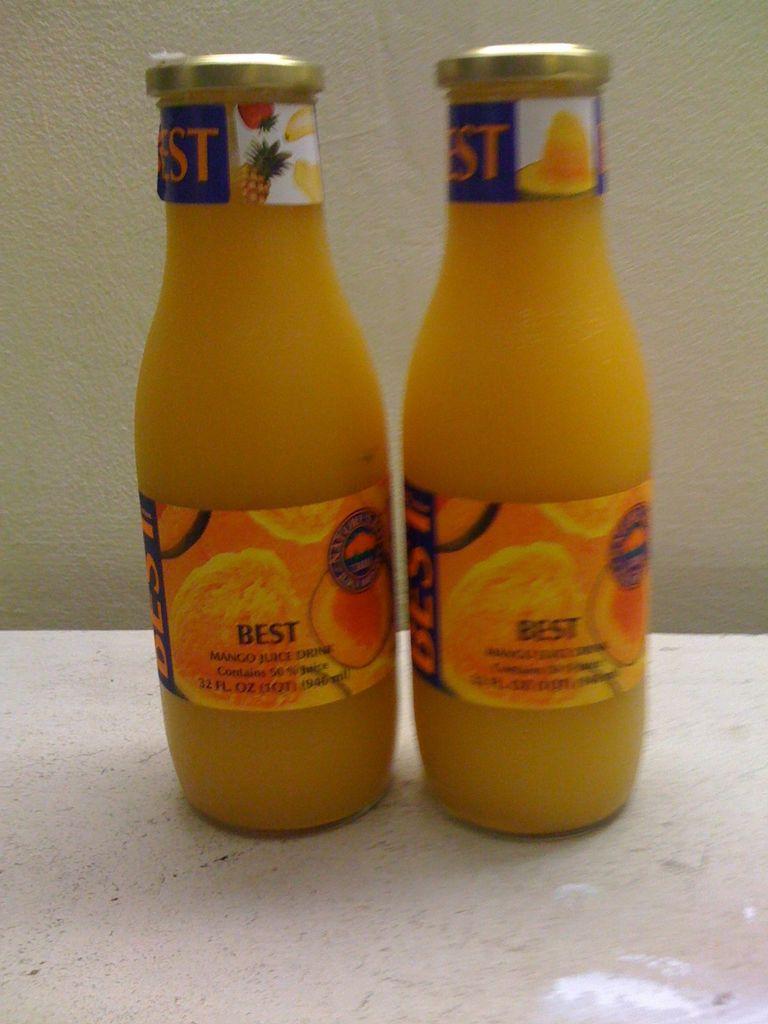What brand of juice is shown?
Give a very brief answer. Best. Does it say whether or not it's the best?
Offer a very short reply. Yes. 